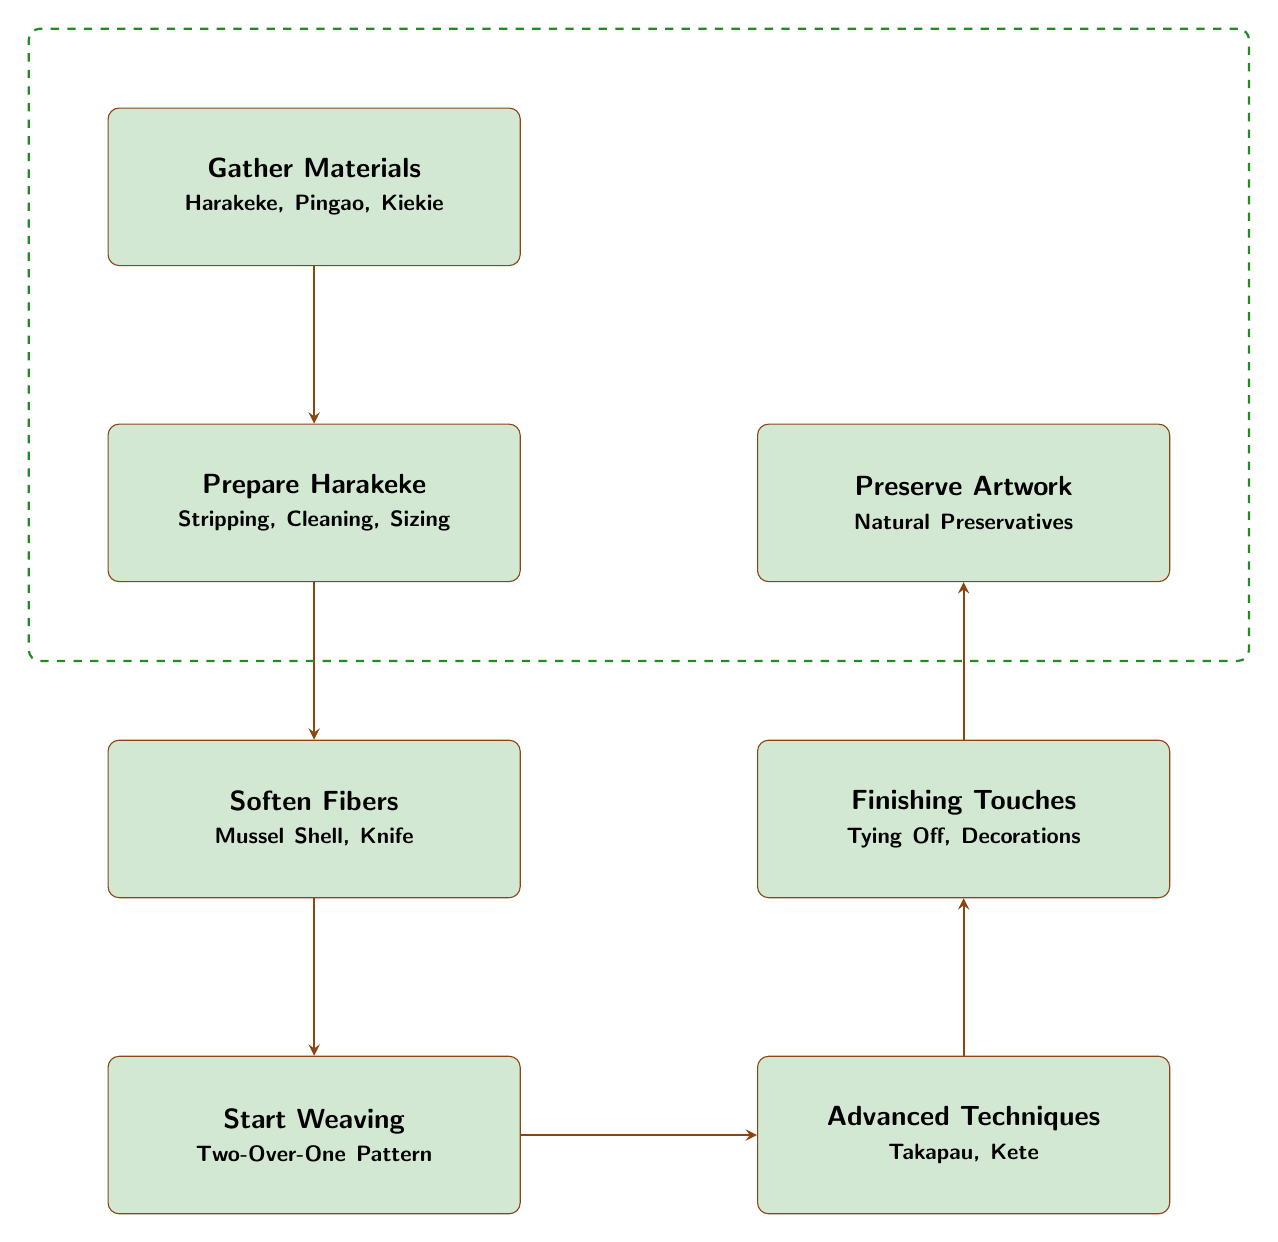What is the first step in the weaving process? The diagram shows a progression of steps, and the first step listed is "Gather Materials". This indicates that collecting materials is essential before proceeding with any weaving actions.
Answer: Gather Materials How many nodes are displayed in the diagram? By counting each rectangular node representing a step in the process, we can identify a total of seven distinct nodes that outline the complete sequence of traditional Maori weaving techniques.
Answer: 7 What do you do after preparing harakeke? According to the flow of the diagram, after the "Prepare Harakeke" step, the next action is to "Soften Fibers". This shows that softening is essential before starting to weave.
Answer: Soften Fibers Which step involves using a mussel shell? The diagram notes that the step "Soften Fibers" includes using a mussel shell as a tool for softening the harakeke fibers. This highlights its importance in the fiber preparation process.
Answer: Soften Fibers What is the last step according to the diagram? The diagram flows from gathering materials through to the final node that describes the last action as "Preserve Artwork", indicating the need for preservation after completing the weaving process.
Answer: Preserve Artwork What are the two advanced techniques mentioned? In the "Advanced Techniques" block, the techniques listed are "Takapau" and "Kete". This indicates that advanced patterns encompass both mat and basket weaving.
Answer: Takapau, Kete What is necessary to complete the weave properly? The diagram indicates that the step "Finishing Touches" includes tying off the ends and adding decorative elements, which are essential actions to ensure the artwork is complete and aesthetic.
Answer: Tying Off, Decorations Which step comes immediately after "Start Weaving"? The step that comes immediately after "Start Weaving" in the flow chart is "Advanced Techniques". This sequence suggests that once basic weaving is initiated, more complex patterns can be introduced.
Answer: Advanced Techniques 